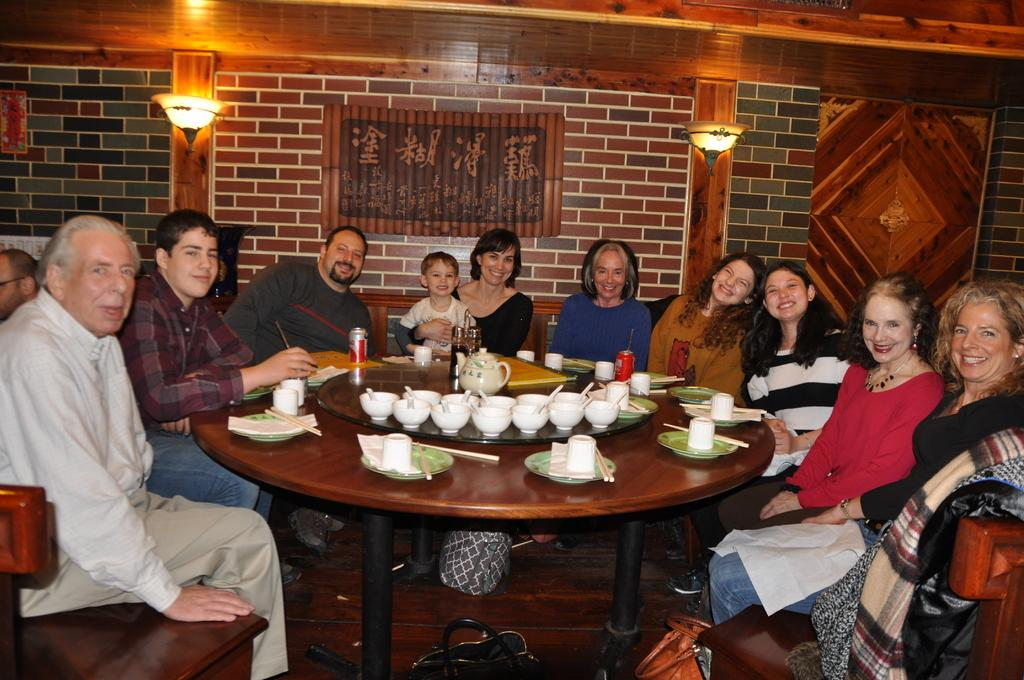What is happening in the image involving a group of people? There is a group of people in the image, and they are sitting on chairs. What can be observed about the people's expressions? The people have smiles on their faces. What activity are the people engaged in? The people are having food. Can you describe the lighting arrangement in the image? There is a lighting arrangement on the wall. Is there a bed visible in the image? No, there is no bed present in the image. 